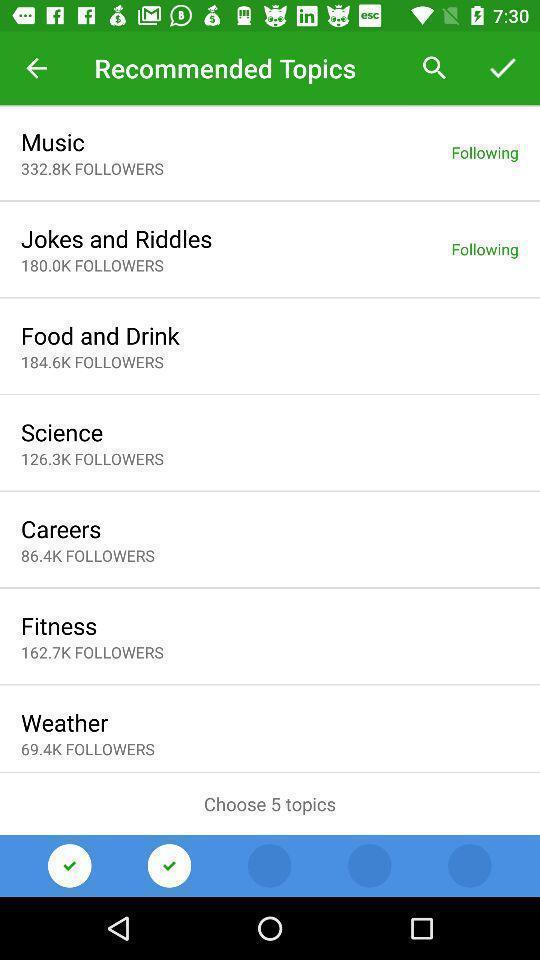Explain what's happening in this screen capture. Page displaying with list of recommended topics. 